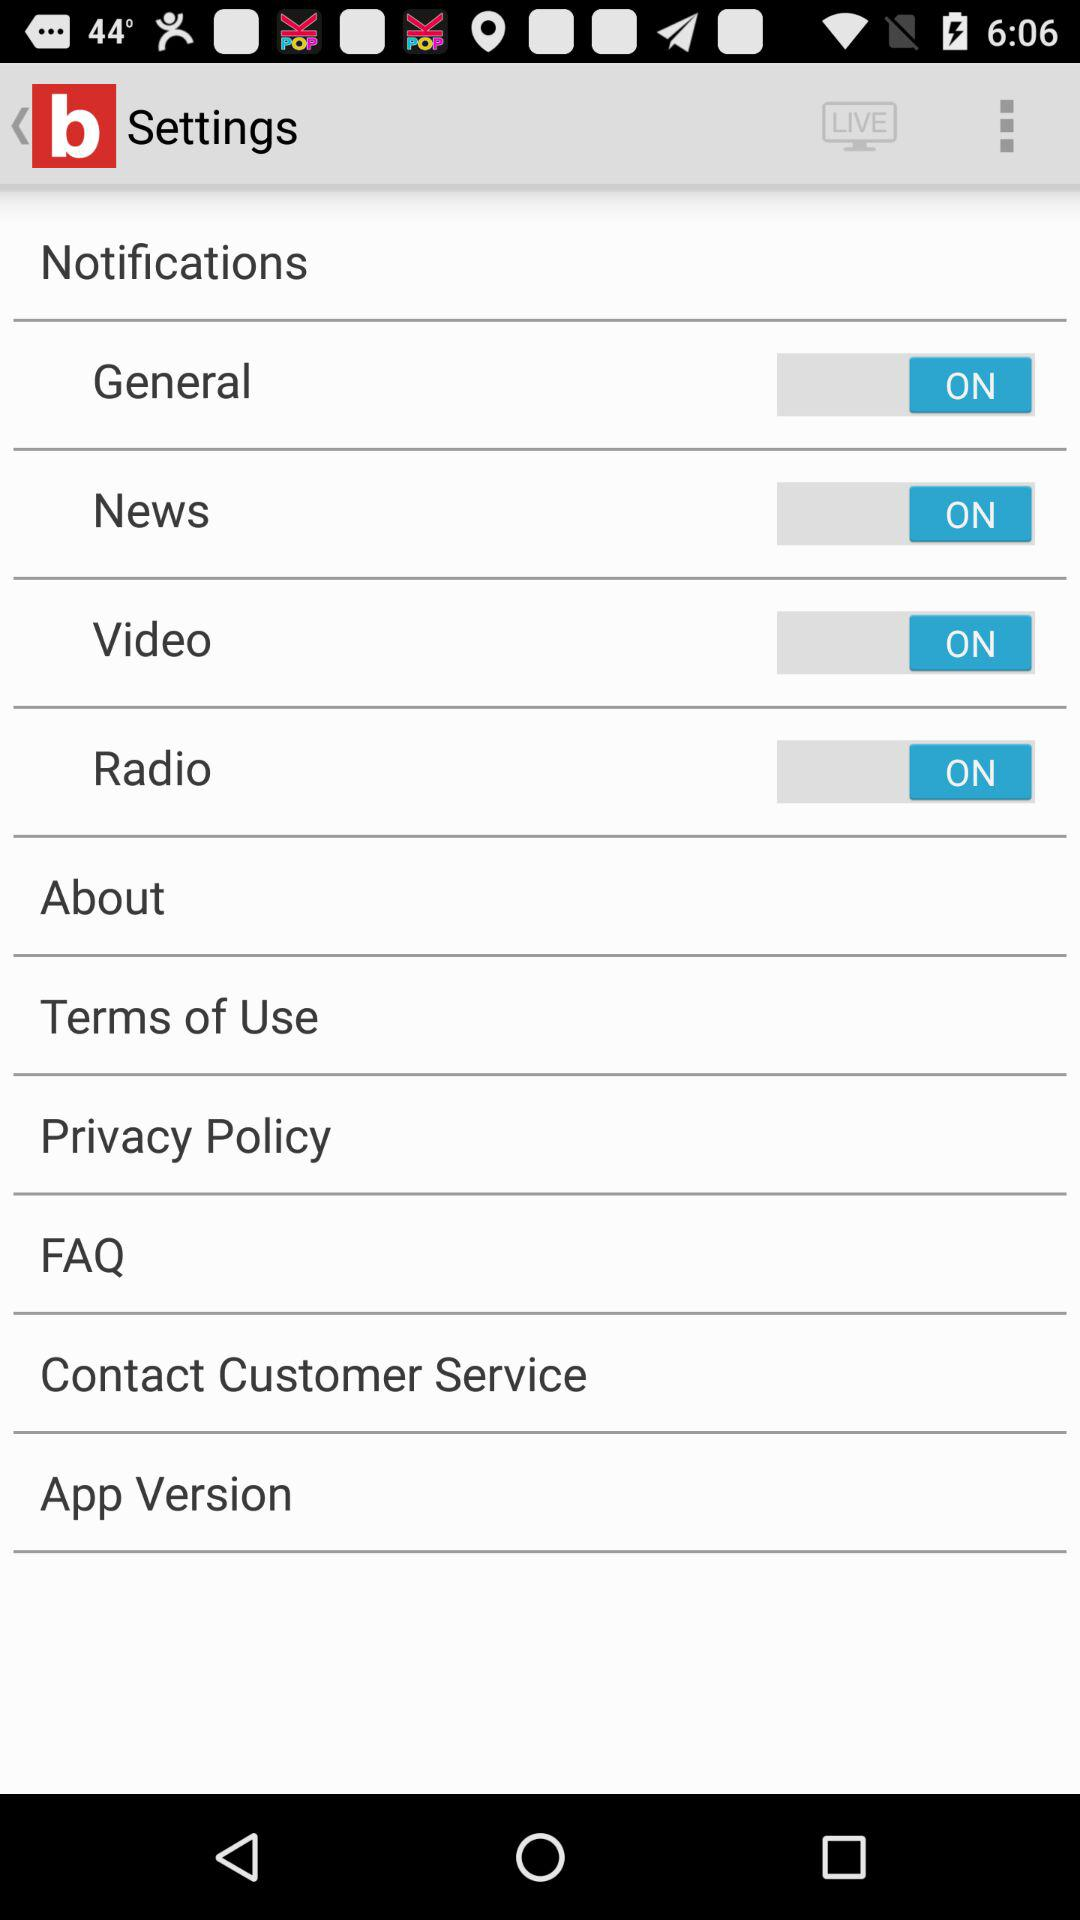What is the current status of the "Video"? The current status is "on". 